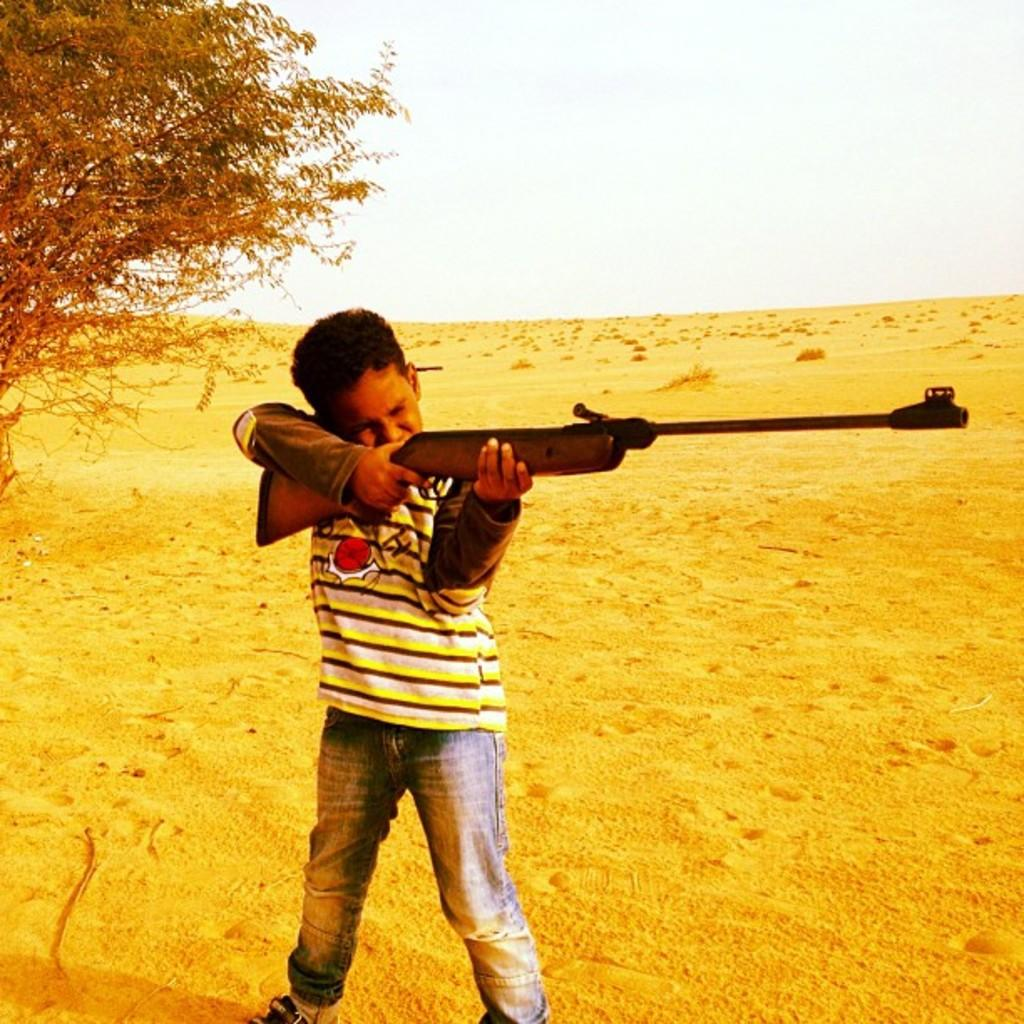What type of terrain is visible in the image? There is sand in the image. What natural element can be seen in the image? There is a tree in the image. What part of the natural environment is visible in the image? The sky is visible in the image. What is the person in the image holding? There is a person holding a gun in the image. What type of statement is being made by the person wearing underwear in the image? There is no person wearing underwear present in the image. How many drops of water can be seen falling from the sky in the image? There are no drops of water visible in the image; it is a clear sky. 